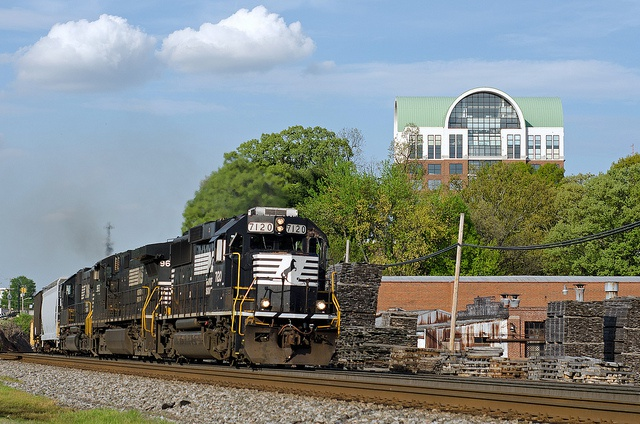Describe the objects in this image and their specific colors. I can see a train in lightblue, black, and gray tones in this image. 